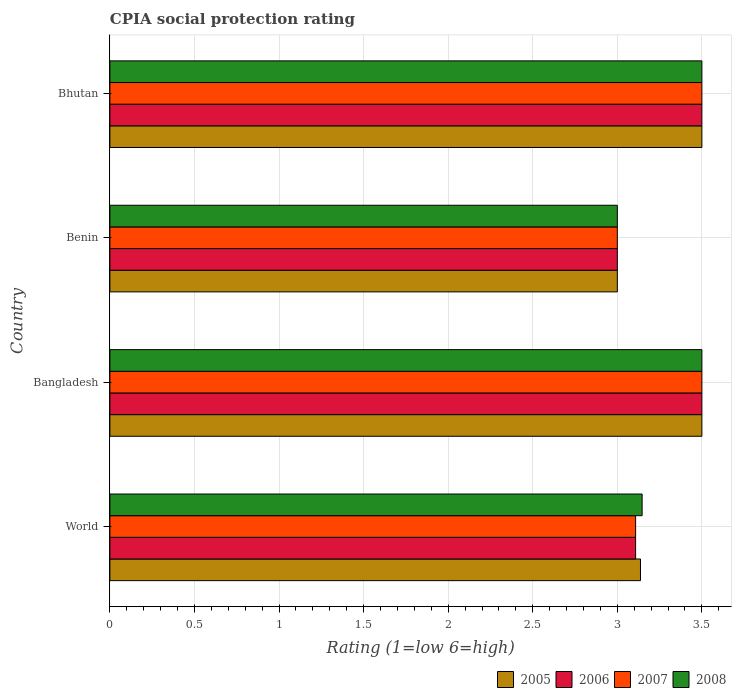How many bars are there on the 2nd tick from the top?
Your answer should be very brief. 4. What is the label of the 2nd group of bars from the top?
Make the answer very short. Benin. Across all countries, what is the maximum CPIA rating in 2008?
Make the answer very short. 3.5. In which country was the CPIA rating in 2006 minimum?
Your answer should be compact. Benin. What is the total CPIA rating in 2005 in the graph?
Keep it short and to the point. 13.14. What is the difference between the CPIA rating in 2005 in Bhutan and the CPIA rating in 2006 in Benin?
Provide a succinct answer. 0.5. What is the average CPIA rating in 2006 per country?
Ensure brevity in your answer.  3.28. What is the ratio of the CPIA rating in 2007 in Bhutan to that in World?
Provide a short and direct response. 1.13. In how many countries, is the CPIA rating in 2007 greater than the average CPIA rating in 2007 taken over all countries?
Offer a terse response. 2. Is the sum of the CPIA rating in 2007 in Bhutan and World greater than the maximum CPIA rating in 2005 across all countries?
Your answer should be compact. Yes. Is it the case that in every country, the sum of the CPIA rating in 2008 and CPIA rating in 2007 is greater than the sum of CPIA rating in 2005 and CPIA rating in 2006?
Your answer should be compact. No. What does the 2nd bar from the bottom in Bangladesh represents?
Make the answer very short. 2006. Are all the bars in the graph horizontal?
Offer a very short reply. Yes. How many countries are there in the graph?
Offer a terse response. 4. Where does the legend appear in the graph?
Your answer should be compact. Bottom right. How many legend labels are there?
Provide a succinct answer. 4. What is the title of the graph?
Your response must be concise. CPIA social protection rating. What is the label or title of the X-axis?
Provide a succinct answer. Rating (1=low 6=high). What is the label or title of the Y-axis?
Ensure brevity in your answer.  Country. What is the Rating (1=low 6=high) in 2005 in World?
Your answer should be compact. 3.14. What is the Rating (1=low 6=high) of 2006 in World?
Make the answer very short. 3.11. What is the Rating (1=low 6=high) of 2007 in World?
Ensure brevity in your answer.  3.11. What is the Rating (1=low 6=high) in 2008 in World?
Offer a very short reply. 3.15. What is the Rating (1=low 6=high) of 2005 in Bangladesh?
Offer a terse response. 3.5. What is the Rating (1=low 6=high) of 2006 in Bangladesh?
Your answer should be compact. 3.5. What is the Rating (1=low 6=high) of 2007 in Benin?
Keep it short and to the point. 3. What is the Rating (1=low 6=high) of 2008 in Benin?
Offer a terse response. 3. What is the Rating (1=low 6=high) in 2005 in Bhutan?
Give a very brief answer. 3.5. What is the Rating (1=low 6=high) of 2008 in Bhutan?
Your response must be concise. 3.5. Across all countries, what is the maximum Rating (1=low 6=high) of 2007?
Your answer should be compact. 3.5. Across all countries, what is the maximum Rating (1=low 6=high) in 2008?
Your answer should be compact. 3.5. Across all countries, what is the minimum Rating (1=low 6=high) in 2006?
Give a very brief answer. 3. What is the total Rating (1=low 6=high) of 2005 in the graph?
Keep it short and to the point. 13.14. What is the total Rating (1=low 6=high) of 2006 in the graph?
Your answer should be compact. 13.11. What is the total Rating (1=low 6=high) in 2007 in the graph?
Give a very brief answer. 13.11. What is the total Rating (1=low 6=high) of 2008 in the graph?
Your response must be concise. 13.15. What is the difference between the Rating (1=low 6=high) in 2005 in World and that in Bangladesh?
Your response must be concise. -0.36. What is the difference between the Rating (1=low 6=high) in 2006 in World and that in Bangladesh?
Provide a succinct answer. -0.39. What is the difference between the Rating (1=low 6=high) of 2007 in World and that in Bangladesh?
Your answer should be compact. -0.39. What is the difference between the Rating (1=low 6=high) in 2008 in World and that in Bangladesh?
Offer a terse response. -0.35. What is the difference between the Rating (1=low 6=high) in 2005 in World and that in Benin?
Your answer should be compact. 0.14. What is the difference between the Rating (1=low 6=high) in 2006 in World and that in Benin?
Provide a short and direct response. 0.11. What is the difference between the Rating (1=low 6=high) in 2007 in World and that in Benin?
Your response must be concise. 0.11. What is the difference between the Rating (1=low 6=high) of 2008 in World and that in Benin?
Give a very brief answer. 0.15. What is the difference between the Rating (1=low 6=high) of 2005 in World and that in Bhutan?
Offer a terse response. -0.36. What is the difference between the Rating (1=low 6=high) in 2006 in World and that in Bhutan?
Offer a terse response. -0.39. What is the difference between the Rating (1=low 6=high) of 2007 in World and that in Bhutan?
Keep it short and to the point. -0.39. What is the difference between the Rating (1=low 6=high) in 2008 in World and that in Bhutan?
Provide a succinct answer. -0.35. What is the difference between the Rating (1=low 6=high) of 2005 in Bangladesh and that in Benin?
Make the answer very short. 0.5. What is the difference between the Rating (1=low 6=high) of 2006 in Bangladesh and that in Benin?
Keep it short and to the point. 0.5. What is the difference between the Rating (1=low 6=high) in 2008 in Bangladesh and that in Benin?
Provide a short and direct response. 0.5. What is the difference between the Rating (1=low 6=high) of 2005 in Bangladesh and that in Bhutan?
Provide a succinct answer. 0. What is the difference between the Rating (1=low 6=high) in 2007 in Bangladesh and that in Bhutan?
Give a very brief answer. 0. What is the difference between the Rating (1=low 6=high) in 2008 in Bangladesh and that in Bhutan?
Ensure brevity in your answer.  0. What is the difference between the Rating (1=low 6=high) in 2008 in Benin and that in Bhutan?
Your answer should be very brief. -0.5. What is the difference between the Rating (1=low 6=high) in 2005 in World and the Rating (1=low 6=high) in 2006 in Bangladesh?
Your answer should be very brief. -0.36. What is the difference between the Rating (1=low 6=high) in 2005 in World and the Rating (1=low 6=high) in 2007 in Bangladesh?
Your answer should be compact. -0.36. What is the difference between the Rating (1=low 6=high) of 2005 in World and the Rating (1=low 6=high) of 2008 in Bangladesh?
Give a very brief answer. -0.36. What is the difference between the Rating (1=low 6=high) of 2006 in World and the Rating (1=low 6=high) of 2007 in Bangladesh?
Provide a short and direct response. -0.39. What is the difference between the Rating (1=low 6=high) in 2006 in World and the Rating (1=low 6=high) in 2008 in Bangladesh?
Make the answer very short. -0.39. What is the difference between the Rating (1=low 6=high) in 2007 in World and the Rating (1=low 6=high) in 2008 in Bangladesh?
Your answer should be compact. -0.39. What is the difference between the Rating (1=low 6=high) of 2005 in World and the Rating (1=low 6=high) of 2006 in Benin?
Offer a terse response. 0.14. What is the difference between the Rating (1=low 6=high) of 2005 in World and the Rating (1=low 6=high) of 2007 in Benin?
Your answer should be very brief. 0.14. What is the difference between the Rating (1=low 6=high) in 2005 in World and the Rating (1=low 6=high) in 2008 in Benin?
Provide a short and direct response. 0.14. What is the difference between the Rating (1=low 6=high) in 2006 in World and the Rating (1=low 6=high) in 2007 in Benin?
Make the answer very short. 0.11. What is the difference between the Rating (1=low 6=high) of 2006 in World and the Rating (1=low 6=high) of 2008 in Benin?
Provide a short and direct response. 0.11. What is the difference between the Rating (1=low 6=high) in 2007 in World and the Rating (1=low 6=high) in 2008 in Benin?
Provide a short and direct response. 0.11. What is the difference between the Rating (1=low 6=high) of 2005 in World and the Rating (1=low 6=high) of 2006 in Bhutan?
Offer a very short reply. -0.36. What is the difference between the Rating (1=low 6=high) of 2005 in World and the Rating (1=low 6=high) of 2007 in Bhutan?
Offer a very short reply. -0.36. What is the difference between the Rating (1=low 6=high) of 2005 in World and the Rating (1=low 6=high) of 2008 in Bhutan?
Your response must be concise. -0.36. What is the difference between the Rating (1=low 6=high) in 2006 in World and the Rating (1=low 6=high) in 2007 in Bhutan?
Offer a terse response. -0.39. What is the difference between the Rating (1=low 6=high) of 2006 in World and the Rating (1=low 6=high) of 2008 in Bhutan?
Your answer should be very brief. -0.39. What is the difference between the Rating (1=low 6=high) in 2007 in World and the Rating (1=low 6=high) in 2008 in Bhutan?
Provide a short and direct response. -0.39. What is the difference between the Rating (1=low 6=high) in 2005 in Bangladesh and the Rating (1=low 6=high) in 2007 in Benin?
Provide a succinct answer. 0.5. What is the difference between the Rating (1=low 6=high) of 2005 in Bangladesh and the Rating (1=low 6=high) of 2008 in Benin?
Your answer should be very brief. 0.5. What is the difference between the Rating (1=low 6=high) in 2006 in Bangladesh and the Rating (1=low 6=high) in 2007 in Benin?
Offer a very short reply. 0.5. What is the difference between the Rating (1=low 6=high) of 2006 in Bangladesh and the Rating (1=low 6=high) of 2008 in Benin?
Provide a succinct answer. 0.5. What is the difference between the Rating (1=low 6=high) in 2005 in Bangladesh and the Rating (1=low 6=high) in 2006 in Bhutan?
Offer a terse response. 0. What is the difference between the Rating (1=low 6=high) of 2005 in Bangladesh and the Rating (1=low 6=high) of 2008 in Bhutan?
Your answer should be very brief. 0. What is the difference between the Rating (1=low 6=high) in 2007 in Bangladesh and the Rating (1=low 6=high) in 2008 in Bhutan?
Ensure brevity in your answer.  0. What is the difference between the Rating (1=low 6=high) of 2005 in Benin and the Rating (1=low 6=high) of 2006 in Bhutan?
Ensure brevity in your answer.  -0.5. What is the difference between the Rating (1=low 6=high) of 2005 in Benin and the Rating (1=low 6=high) of 2007 in Bhutan?
Ensure brevity in your answer.  -0.5. What is the difference between the Rating (1=low 6=high) in 2005 in Benin and the Rating (1=low 6=high) in 2008 in Bhutan?
Your answer should be compact. -0.5. What is the difference between the Rating (1=low 6=high) in 2006 in Benin and the Rating (1=low 6=high) in 2007 in Bhutan?
Offer a terse response. -0.5. What is the difference between the Rating (1=low 6=high) of 2007 in Benin and the Rating (1=low 6=high) of 2008 in Bhutan?
Offer a terse response. -0.5. What is the average Rating (1=low 6=high) in 2005 per country?
Keep it short and to the point. 3.28. What is the average Rating (1=low 6=high) in 2006 per country?
Ensure brevity in your answer.  3.28. What is the average Rating (1=low 6=high) in 2007 per country?
Give a very brief answer. 3.28. What is the average Rating (1=low 6=high) in 2008 per country?
Give a very brief answer. 3.29. What is the difference between the Rating (1=low 6=high) in 2005 and Rating (1=low 6=high) in 2006 in World?
Your answer should be compact. 0.03. What is the difference between the Rating (1=low 6=high) in 2005 and Rating (1=low 6=high) in 2007 in World?
Provide a short and direct response. 0.03. What is the difference between the Rating (1=low 6=high) in 2005 and Rating (1=low 6=high) in 2008 in World?
Your answer should be compact. -0.01. What is the difference between the Rating (1=low 6=high) in 2006 and Rating (1=low 6=high) in 2007 in World?
Make the answer very short. 0. What is the difference between the Rating (1=low 6=high) in 2006 and Rating (1=low 6=high) in 2008 in World?
Make the answer very short. -0.04. What is the difference between the Rating (1=low 6=high) in 2007 and Rating (1=low 6=high) in 2008 in World?
Give a very brief answer. -0.04. What is the difference between the Rating (1=low 6=high) in 2005 and Rating (1=low 6=high) in 2007 in Bangladesh?
Offer a terse response. 0. What is the difference between the Rating (1=low 6=high) of 2006 and Rating (1=low 6=high) of 2007 in Bangladesh?
Give a very brief answer. 0. What is the difference between the Rating (1=low 6=high) in 2006 and Rating (1=low 6=high) in 2008 in Bangladesh?
Offer a very short reply. 0. What is the difference between the Rating (1=low 6=high) in 2005 and Rating (1=low 6=high) in 2008 in Benin?
Offer a terse response. 0. What is the difference between the Rating (1=low 6=high) of 2007 and Rating (1=low 6=high) of 2008 in Benin?
Give a very brief answer. 0. What is the difference between the Rating (1=low 6=high) in 2005 and Rating (1=low 6=high) in 2007 in Bhutan?
Ensure brevity in your answer.  0. What is the difference between the Rating (1=low 6=high) in 2005 and Rating (1=low 6=high) in 2008 in Bhutan?
Make the answer very short. 0. What is the difference between the Rating (1=low 6=high) in 2007 and Rating (1=low 6=high) in 2008 in Bhutan?
Provide a succinct answer. 0. What is the ratio of the Rating (1=low 6=high) in 2005 in World to that in Bangladesh?
Make the answer very short. 0.9. What is the ratio of the Rating (1=low 6=high) of 2006 in World to that in Bangladesh?
Provide a succinct answer. 0.89. What is the ratio of the Rating (1=low 6=high) of 2007 in World to that in Bangladesh?
Your answer should be very brief. 0.89. What is the ratio of the Rating (1=low 6=high) of 2008 in World to that in Bangladesh?
Make the answer very short. 0.9. What is the ratio of the Rating (1=low 6=high) of 2005 in World to that in Benin?
Keep it short and to the point. 1.05. What is the ratio of the Rating (1=low 6=high) in 2006 in World to that in Benin?
Your response must be concise. 1.04. What is the ratio of the Rating (1=low 6=high) of 2007 in World to that in Benin?
Your answer should be very brief. 1.04. What is the ratio of the Rating (1=low 6=high) of 2008 in World to that in Benin?
Provide a succinct answer. 1.05. What is the ratio of the Rating (1=low 6=high) in 2005 in World to that in Bhutan?
Provide a short and direct response. 0.9. What is the ratio of the Rating (1=low 6=high) in 2006 in World to that in Bhutan?
Your answer should be very brief. 0.89. What is the ratio of the Rating (1=low 6=high) in 2007 in World to that in Bhutan?
Ensure brevity in your answer.  0.89. What is the ratio of the Rating (1=low 6=high) in 2008 in World to that in Bhutan?
Give a very brief answer. 0.9. What is the ratio of the Rating (1=low 6=high) of 2006 in Bangladesh to that in Benin?
Provide a succinct answer. 1.17. What is the ratio of the Rating (1=low 6=high) of 2007 in Bangladesh to that in Benin?
Make the answer very short. 1.17. What is the ratio of the Rating (1=low 6=high) in 2006 in Bangladesh to that in Bhutan?
Your response must be concise. 1. What is the ratio of the Rating (1=low 6=high) of 2005 in Benin to that in Bhutan?
Offer a terse response. 0.86. What is the ratio of the Rating (1=low 6=high) of 2006 in Benin to that in Bhutan?
Your answer should be compact. 0.86. What is the difference between the highest and the second highest Rating (1=low 6=high) of 2006?
Your answer should be very brief. 0. What is the difference between the highest and the lowest Rating (1=low 6=high) of 2005?
Offer a terse response. 0.5. What is the difference between the highest and the lowest Rating (1=low 6=high) in 2007?
Your answer should be compact. 0.5. 